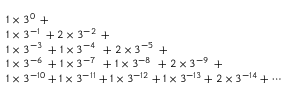Convert formula to latex. <formula><loc_0><loc_0><loc_500><loc_500>{ \begin{array} { l } { 1 \times 3 ^ { 0 \, } + } \\ { 1 \times 3 ^ { - 1 \, } + 2 \times 3 ^ { - 2 \, } + } \\ { 1 \times 3 ^ { - 3 \, } + 1 \times 3 ^ { - 4 \, } + 2 \times 3 ^ { - 5 \, } + } \\ { 1 \times 3 ^ { - 6 \, } + 1 \times 3 ^ { - 7 \, } + 1 \times 3 ^ { - 8 \, } + 2 \times 3 ^ { - 9 \, } + } \\ { 1 \times 3 ^ { - 1 0 } + 1 \times 3 ^ { - 1 1 } + 1 \times 3 ^ { - 1 2 } + 1 \times 3 ^ { - 1 3 } + 2 \times 3 ^ { - 1 4 } + \cdots } \end{array} }</formula> 